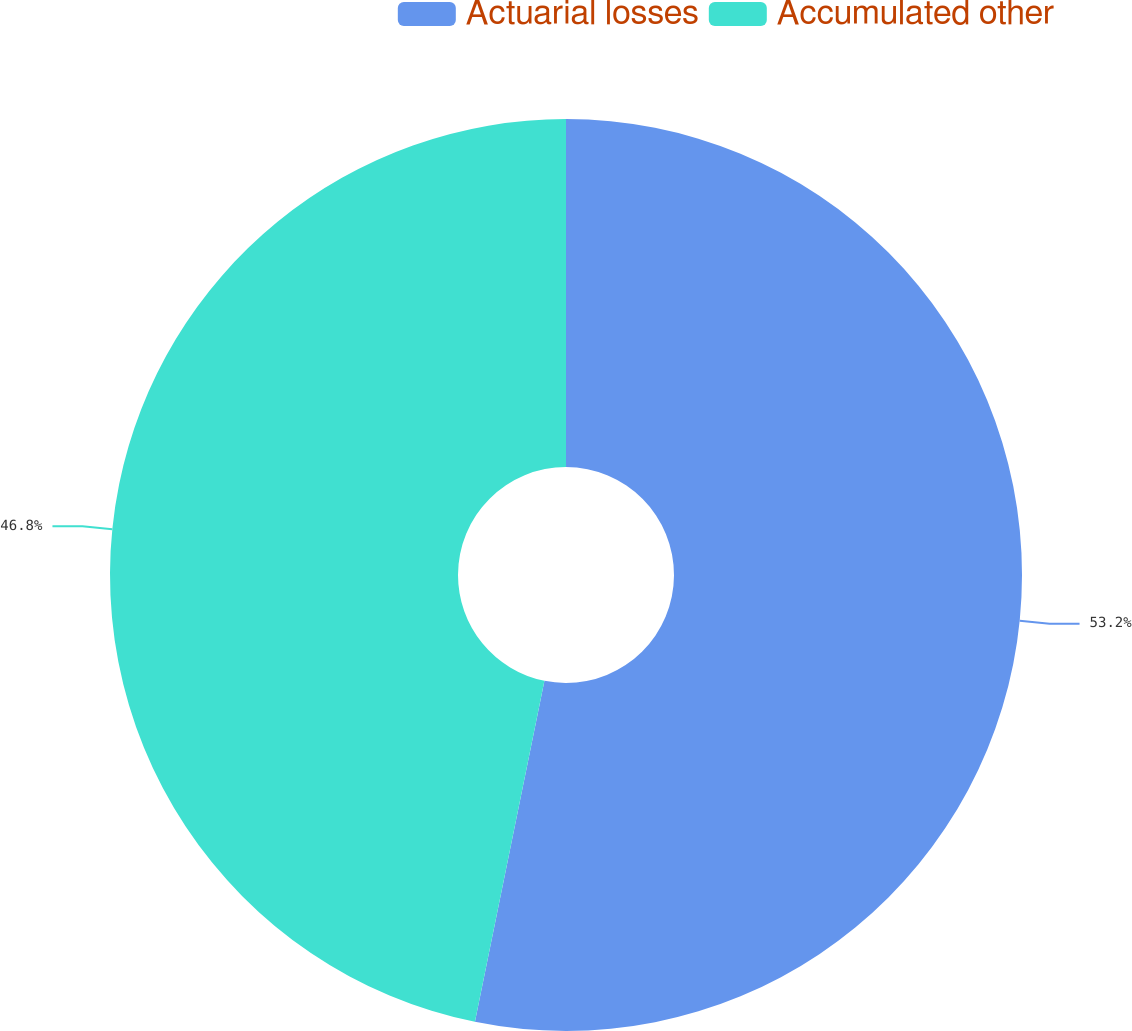<chart> <loc_0><loc_0><loc_500><loc_500><pie_chart><fcel>Actuarial losses<fcel>Accumulated other<nl><fcel>53.2%<fcel>46.8%<nl></chart> 